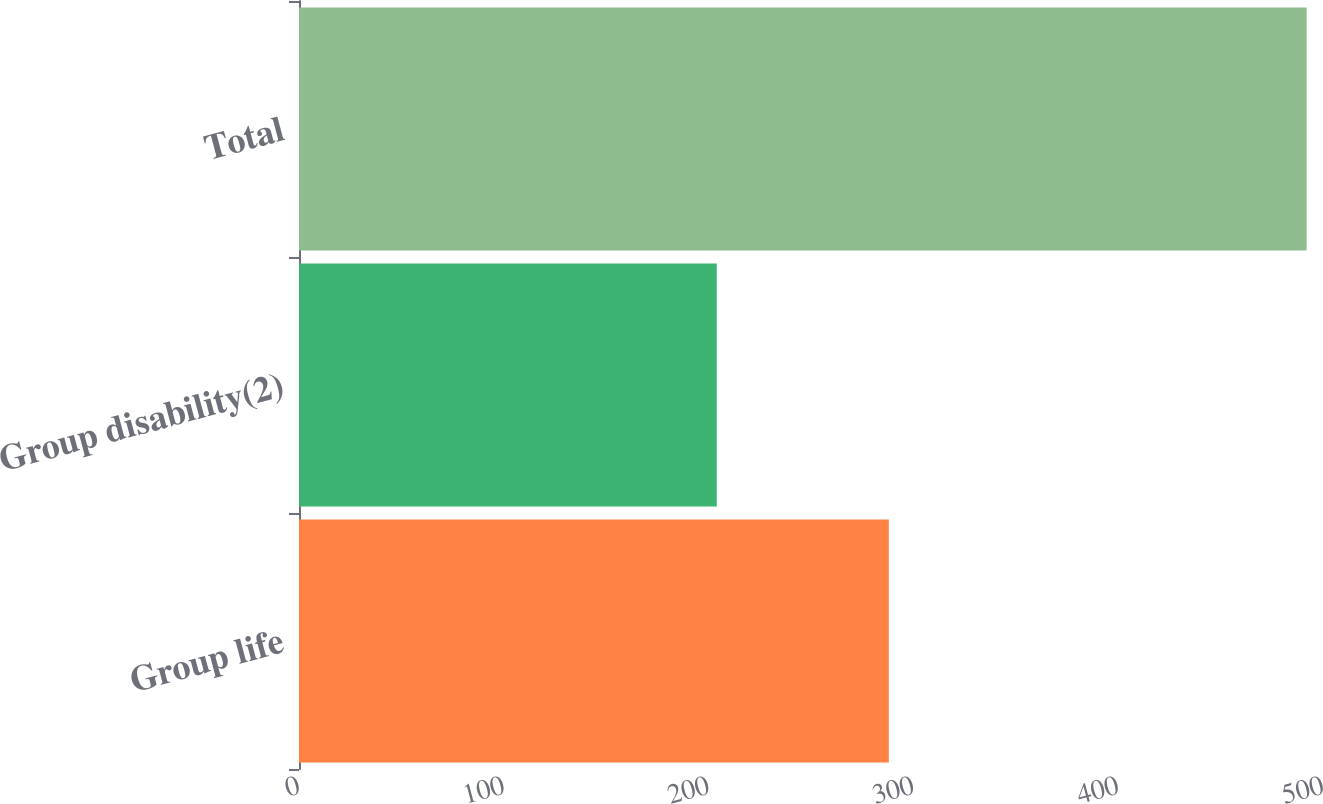<chart> <loc_0><loc_0><loc_500><loc_500><bar_chart><fcel>Group life<fcel>Group disability(2)<fcel>Total<nl><fcel>288<fcel>204<fcel>492<nl></chart> 